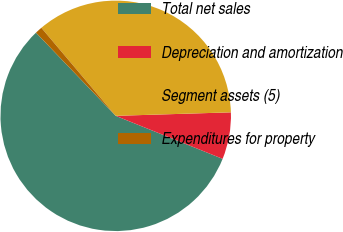Convert chart. <chart><loc_0><loc_0><loc_500><loc_500><pie_chart><fcel>Total net sales<fcel>Depreciation and amortization<fcel>Segment assets (5)<fcel>Expenditures for property<nl><fcel>56.75%<fcel>6.57%<fcel>35.68%<fcel>1.0%<nl></chart> 